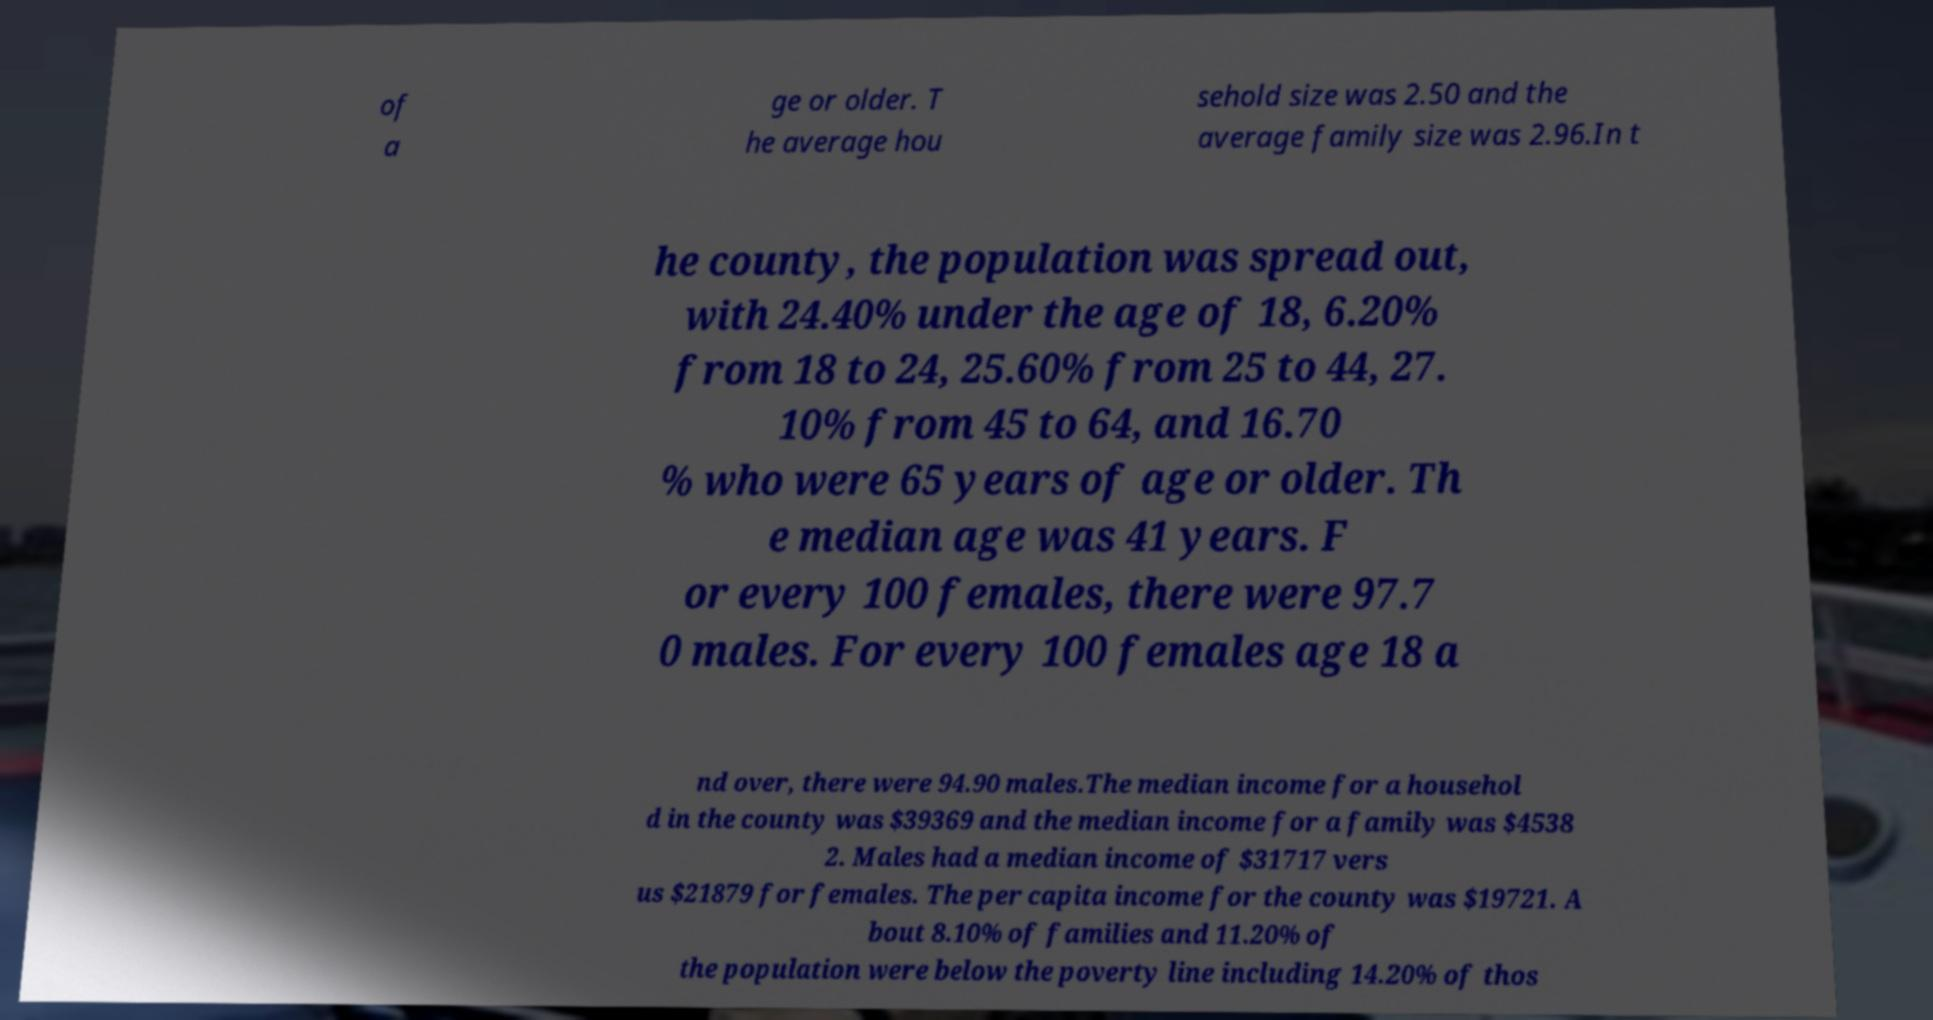Please identify and transcribe the text found in this image. of a ge or older. T he average hou sehold size was 2.50 and the average family size was 2.96.In t he county, the population was spread out, with 24.40% under the age of 18, 6.20% from 18 to 24, 25.60% from 25 to 44, 27. 10% from 45 to 64, and 16.70 % who were 65 years of age or older. Th e median age was 41 years. F or every 100 females, there were 97.7 0 males. For every 100 females age 18 a nd over, there were 94.90 males.The median income for a househol d in the county was $39369 and the median income for a family was $4538 2. Males had a median income of $31717 vers us $21879 for females. The per capita income for the county was $19721. A bout 8.10% of families and 11.20% of the population were below the poverty line including 14.20% of thos 